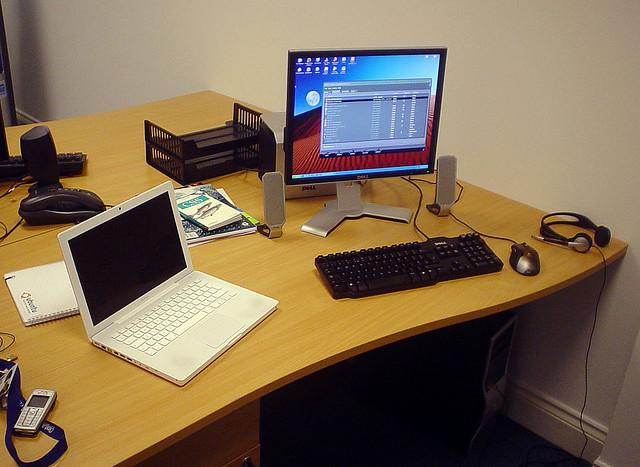What are the two standing rectangular devices?

Choices:
A) microphone
B) speakers
C) power supply
D) phone speakers 